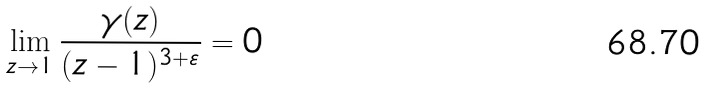<formula> <loc_0><loc_0><loc_500><loc_500>\lim _ { z \rightarrow 1 } \frac { \gamma ( z ) } { ( z - 1 ) ^ { 3 + \varepsilon } } = 0</formula> 